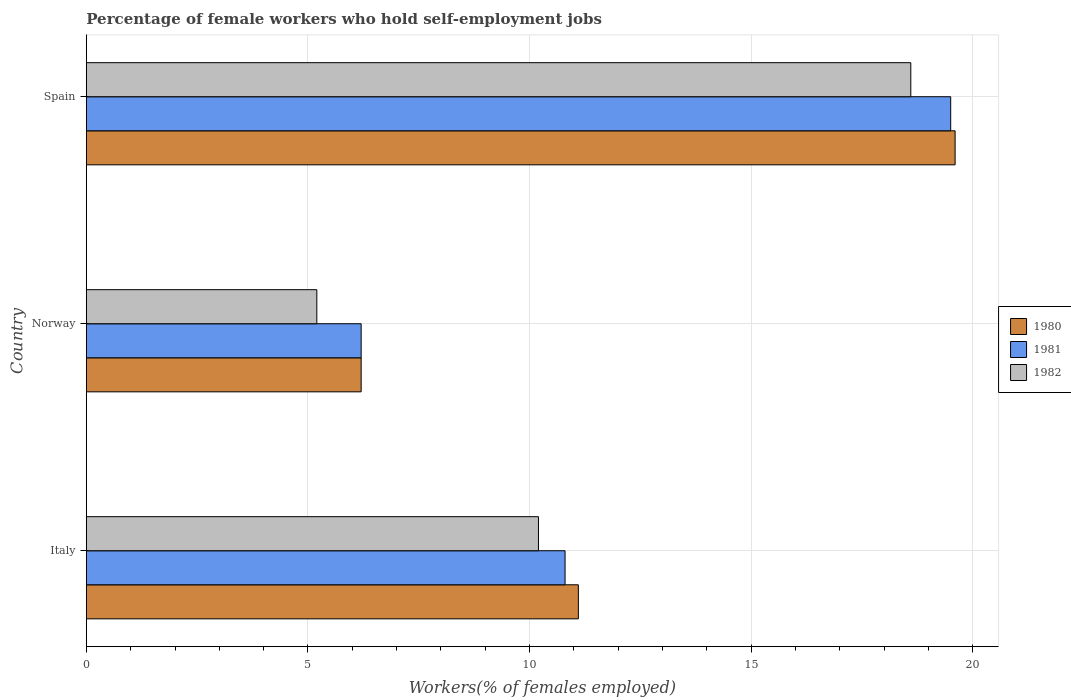How many different coloured bars are there?
Offer a terse response. 3. How many groups of bars are there?
Provide a succinct answer. 3. Are the number of bars per tick equal to the number of legend labels?
Provide a succinct answer. Yes. Are the number of bars on each tick of the Y-axis equal?
Give a very brief answer. Yes. What is the percentage of self-employed female workers in 1980 in Italy?
Provide a short and direct response. 11.1. Across all countries, what is the maximum percentage of self-employed female workers in 1982?
Make the answer very short. 18.6. Across all countries, what is the minimum percentage of self-employed female workers in 1982?
Provide a short and direct response. 5.2. What is the total percentage of self-employed female workers in 1980 in the graph?
Offer a very short reply. 36.9. What is the difference between the percentage of self-employed female workers in 1980 in Italy and that in Spain?
Ensure brevity in your answer.  -8.5. What is the difference between the percentage of self-employed female workers in 1981 in Italy and the percentage of self-employed female workers in 1980 in Norway?
Your response must be concise. 4.6. What is the average percentage of self-employed female workers in 1981 per country?
Provide a succinct answer. 12.17. What is the difference between the percentage of self-employed female workers in 1982 and percentage of self-employed female workers in 1981 in Spain?
Provide a succinct answer. -0.9. In how many countries, is the percentage of self-employed female workers in 1980 greater than 4 %?
Ensure brevity in your answer.  3. What is the ratio of the percentage of self-employed female workers in 1981 in Italy to that in Spain?
Offer a very short reply. 0.55. Is the percentage of self-employed female workers in 1982 in Norway less than that in Spain?
Offer a very short reply. Yes. Is the difference between the percentage of self-employed female workers in 1982 in Italy and Spain greater than the difference between the percentage of self-employed female workers in 1981 in Italy and Spain?
Your answer should be compact. Yes. What is the difference between the highest and the second highest percentage of self-employed female workers in 1981?
Give a very brief answer. 8.7. What is the difference between the highest and the lowest percentage of self-employed female workers in 1980?
Ensure brevity in your answer.  13.4. In how many countries, is the percentage of self-employed female workers in 1981 greater than the average percentage of self-employed female workers in 1981 taken over all countries?
Offer a terse response. 1. What does the 3rd bar from the bottom in Spain represents?
Provide a short and direct response. 1982. How many countries are there in the graph?
Give a very brief answer. 3. What is the difference between two consecutive major ticks on the X-axis?
Keep it short and to the point. 5. Does the graph contain any zero values?
Keep it short and to the point. No. Does the graph contain grids?
Provide a succinct answer. Yes. How many legend labels are there?
Ensure brevity in your answer.  3. What is the title of the graph?
Make the answer very short. Percentage of female workers who hold self-employment jobs. Does "2001" appear as one of the legend labels in the graph?
Your answer should be very brief. No. What is the label or title of the X-axis?
Provide a short and direct response. Workers(% of females employed). What is the label or title of the Y-axis?
Give a very brief answer. Country. What is the Workers(% of females employed) in 1980 in Italy?
Your response must be concise. 11.1. What is the Workers(% of females employed) of 1981 in Italy?
Ensure brevity in your answer.  10.8. What is the Workers(% of females employed) in 1982 in Italy?
Give a very brief answer. 10.2. What is the Workers(% of females employed) in 1980 in Norway?
Your answer should be compact. 6.2. What is the Workers(% of females employed) of 1981 in Norway?
Keep it short and to the point. 6.2. What is the Workers(% of females employed) in 1982 in Norway?
Provide a succinct answer. 5.2. What is the Workers(% of females employed) in 1980 in Spain?
Your answer should be very brief. 19.6. What is the Workers(% of females employed) in 1982 in Spain?
Offer a very short reply. 18.6. Across all countries, what is the maximum Workers(% of females employed) of 1980?
Make the answer very short. 19.6. Across all countries, what is the maximum Workers(% of females employed) of 1982?
Your answer should be compact. 18.6. Across all countries, what is the minimum Workers(% of females employed) of 1980?
Ensure brevity in your answer.  6.2. Across all countries, what is the minimum Workers(% of females employed) in 1981?
Ensure brevity in your answer.  6.2. Across all countries, what is the minimum Workers(% of females employed) in 1982?
Provide a short and direct response. 5.2. What is the total Workers(% of females employed) in 1980 in the graph?
Keep it short and to the point. 36.9. What is the total Workers(% of females employed) in 1981 in the graph?
Give a very brief answer. 36.5. What is the total Workers(% of females employed) of 1982 in the graph?
Offer a very short reply. 34. What is the difference between the Workers(% of females employed) in 1980 in Italy and that in Norway?
Offer a terse response. 4.9. What is the difference between the Workers(% of females employed) in 1981 in Italy and that in Norway?
Make the answer very short. 4.6. What is the difference between the Workers(% of females employed) in 1982 in Italy and that in Norway?
Provide a succinct answer. 5. What is the difference between the Workers(% of females employed) in 1980 in Norway and that in Spain?
Your answer should be compact. -13.4. What is the difference between the Workers(% of females employed) of 1981 in Norway and that in Spain?
Your response must be concise. -13.3. What is the difference between the Workers(% of females employed) of 1982 in Norway and that in Spain?
Offer a terse response. -13.4. What is the difference between the Workers(% of females employed) in 1980 in Italy and the Workers(% of females employed) in 1982 in Norway?
Ensure brevity in your answer.  5.9. What is the difference between the Workers(% of females employed) of 1981 in Italy and the Workers(% of females employed) of 1982 in Spain?
Ensure brevity in your answer.  -7.8. What is the difference between the Workers(% of females employed) in 1980 in Norway and the Workers(% of females employed) in 1982 in Spain?
Make the answer very short. -12.4. What is the difference between the Workers(% of females employed) of 1981 in Norway and the Workers(% of females employed) of 1982 in Spain?
Offer a very short reply. -12.4. What is the average Workers(% of females employed) of 1980 per country?
Provide a succinct answer. 12.3. What is the average Workers(% of females employed) in 1981 per country?
Offer a terse response. 12.17. What is the average Workers(% of females employed) in 1982 per country?
Ensure brevity in your answer.  11.33. What is the difference between the Workers(% of females employed) in 1980 and Workers(% of females employed) in 1981 in Norway?
Give a very brief answer. 0. What is the difference between the Workers(% of females employed) in 1980 and Workers(% of females employed) in 1982 in Norway?
Ensure brevity in your answer.  1. What is the difference between the Workers(% of females employed) in 1981 and Workers(% of females employed) in 1982 in Norway?
Make the answer very short. 1. What is the difference between the Workers(% of females employed) of 1980 and Workers(% of females employed) of 1981 in Spain?
Your answer should be compact. 0.1. What is the difference between the Workers(% of females employed) of 1981 and Workers(% of females employed) of 1982 in Spain?
Make the answer very short. 0.9. What is the ratio of the Workers(% of females employed) of 1980 in Italy to that in Norway?
Your answer should be compact. 1.79. What is the ratio of the Workers(% of females employed) of 1981 in Italy to that in Norway?
Offer a very short reply. 1.74. What is the ratio of the Workers(% of females employed) of 1982 in Italy to that in Norway?
Keep it short and to the point. 1.96. What is the ratio of the Workers(% of females employed) of 1980 in Italy to that in Spain?
Give a very brief answer. 0.57. What is the ratio of the Workers(% of females employed) of 1981 in Italy to that in Spain?
Your answer should be very brief. 0.55. What is the ratio of the Workers(% of females employed) in 1982 in Italy to that in Spain?
Give a very brief answer. 0.55. What is the ratio of the Workers(% of females employed) of 1980 in Norway to that in Spain?
Give a very brief answer. 0.32. What is the ratio of the Workers(% of females employed) in 1981 in Norway to that in Spain?
Offer a very short reply. 0.32. What is the ratio of the Workers(% of females employed) in 1982 in Norway to that in Spain?
Your answer should be compact. 0.28. What is the difference between the highest and the second highest Workers(% of females employed) in 1980?
Ensure brevity in your answer.  8.5. What is the difference between the highest and the second highest Workers(% of females employed) in 1981?
Give a very brief answer. 8.7. What is the difference between the highest and the lowest Workers(% of females employed) of 1980?
Your response must be concise. 13.4. What is the difference between the highest and the lowest Workers(% of females employed) of 1982?
Your answer should be very brief. 13.4. 